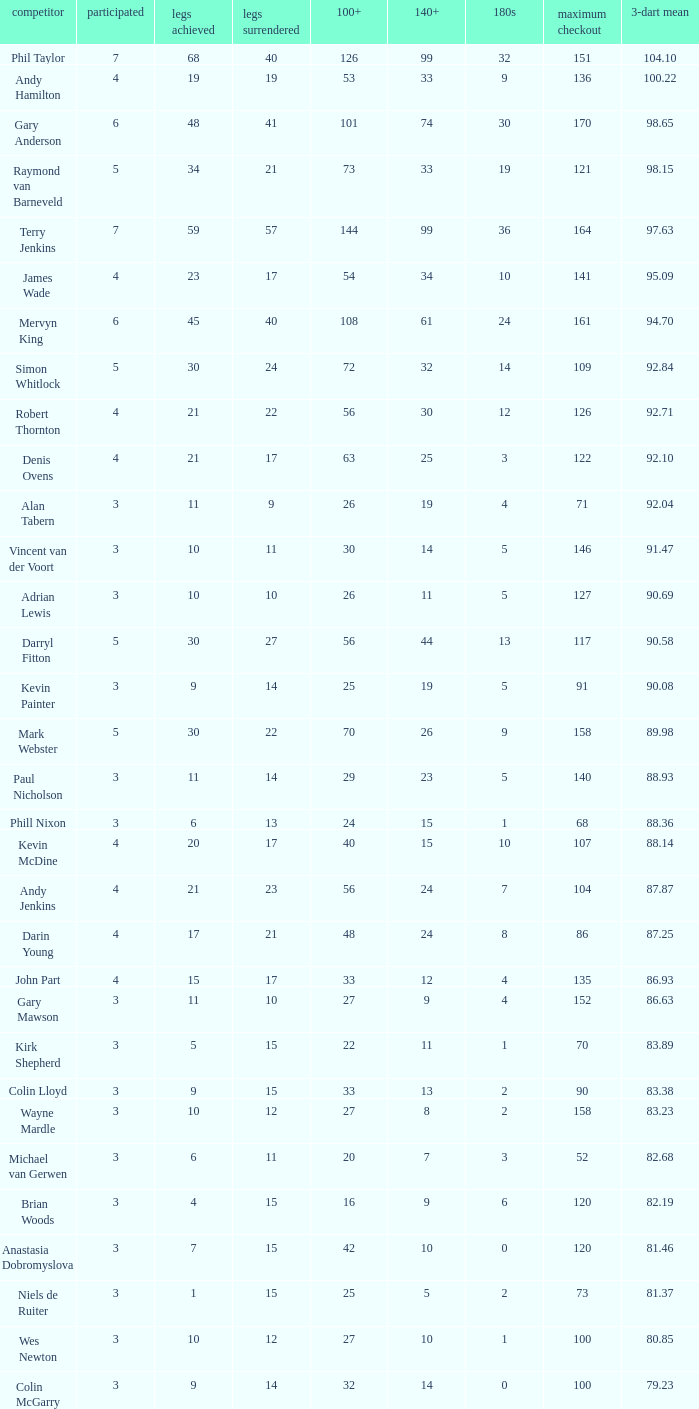What is the lowest high checkout when 140+ is 61, and played is larger than 6? None. 